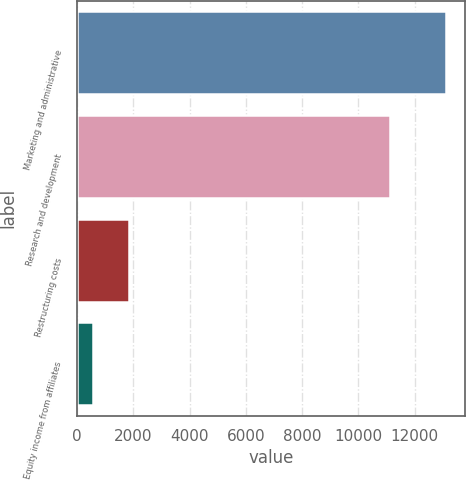Convert chart to OTSL. <chart><loc_0><loc_0><loc_500><loc_500><bar_chart><fcel>Marketing and administrative<fcel>Research and development<fcel>Restructuring costs<fcel>Equity income from affiliates<nl><fcel>13125<fcel>11111<fcel>1840.8<fcel>587<nl></chart> 